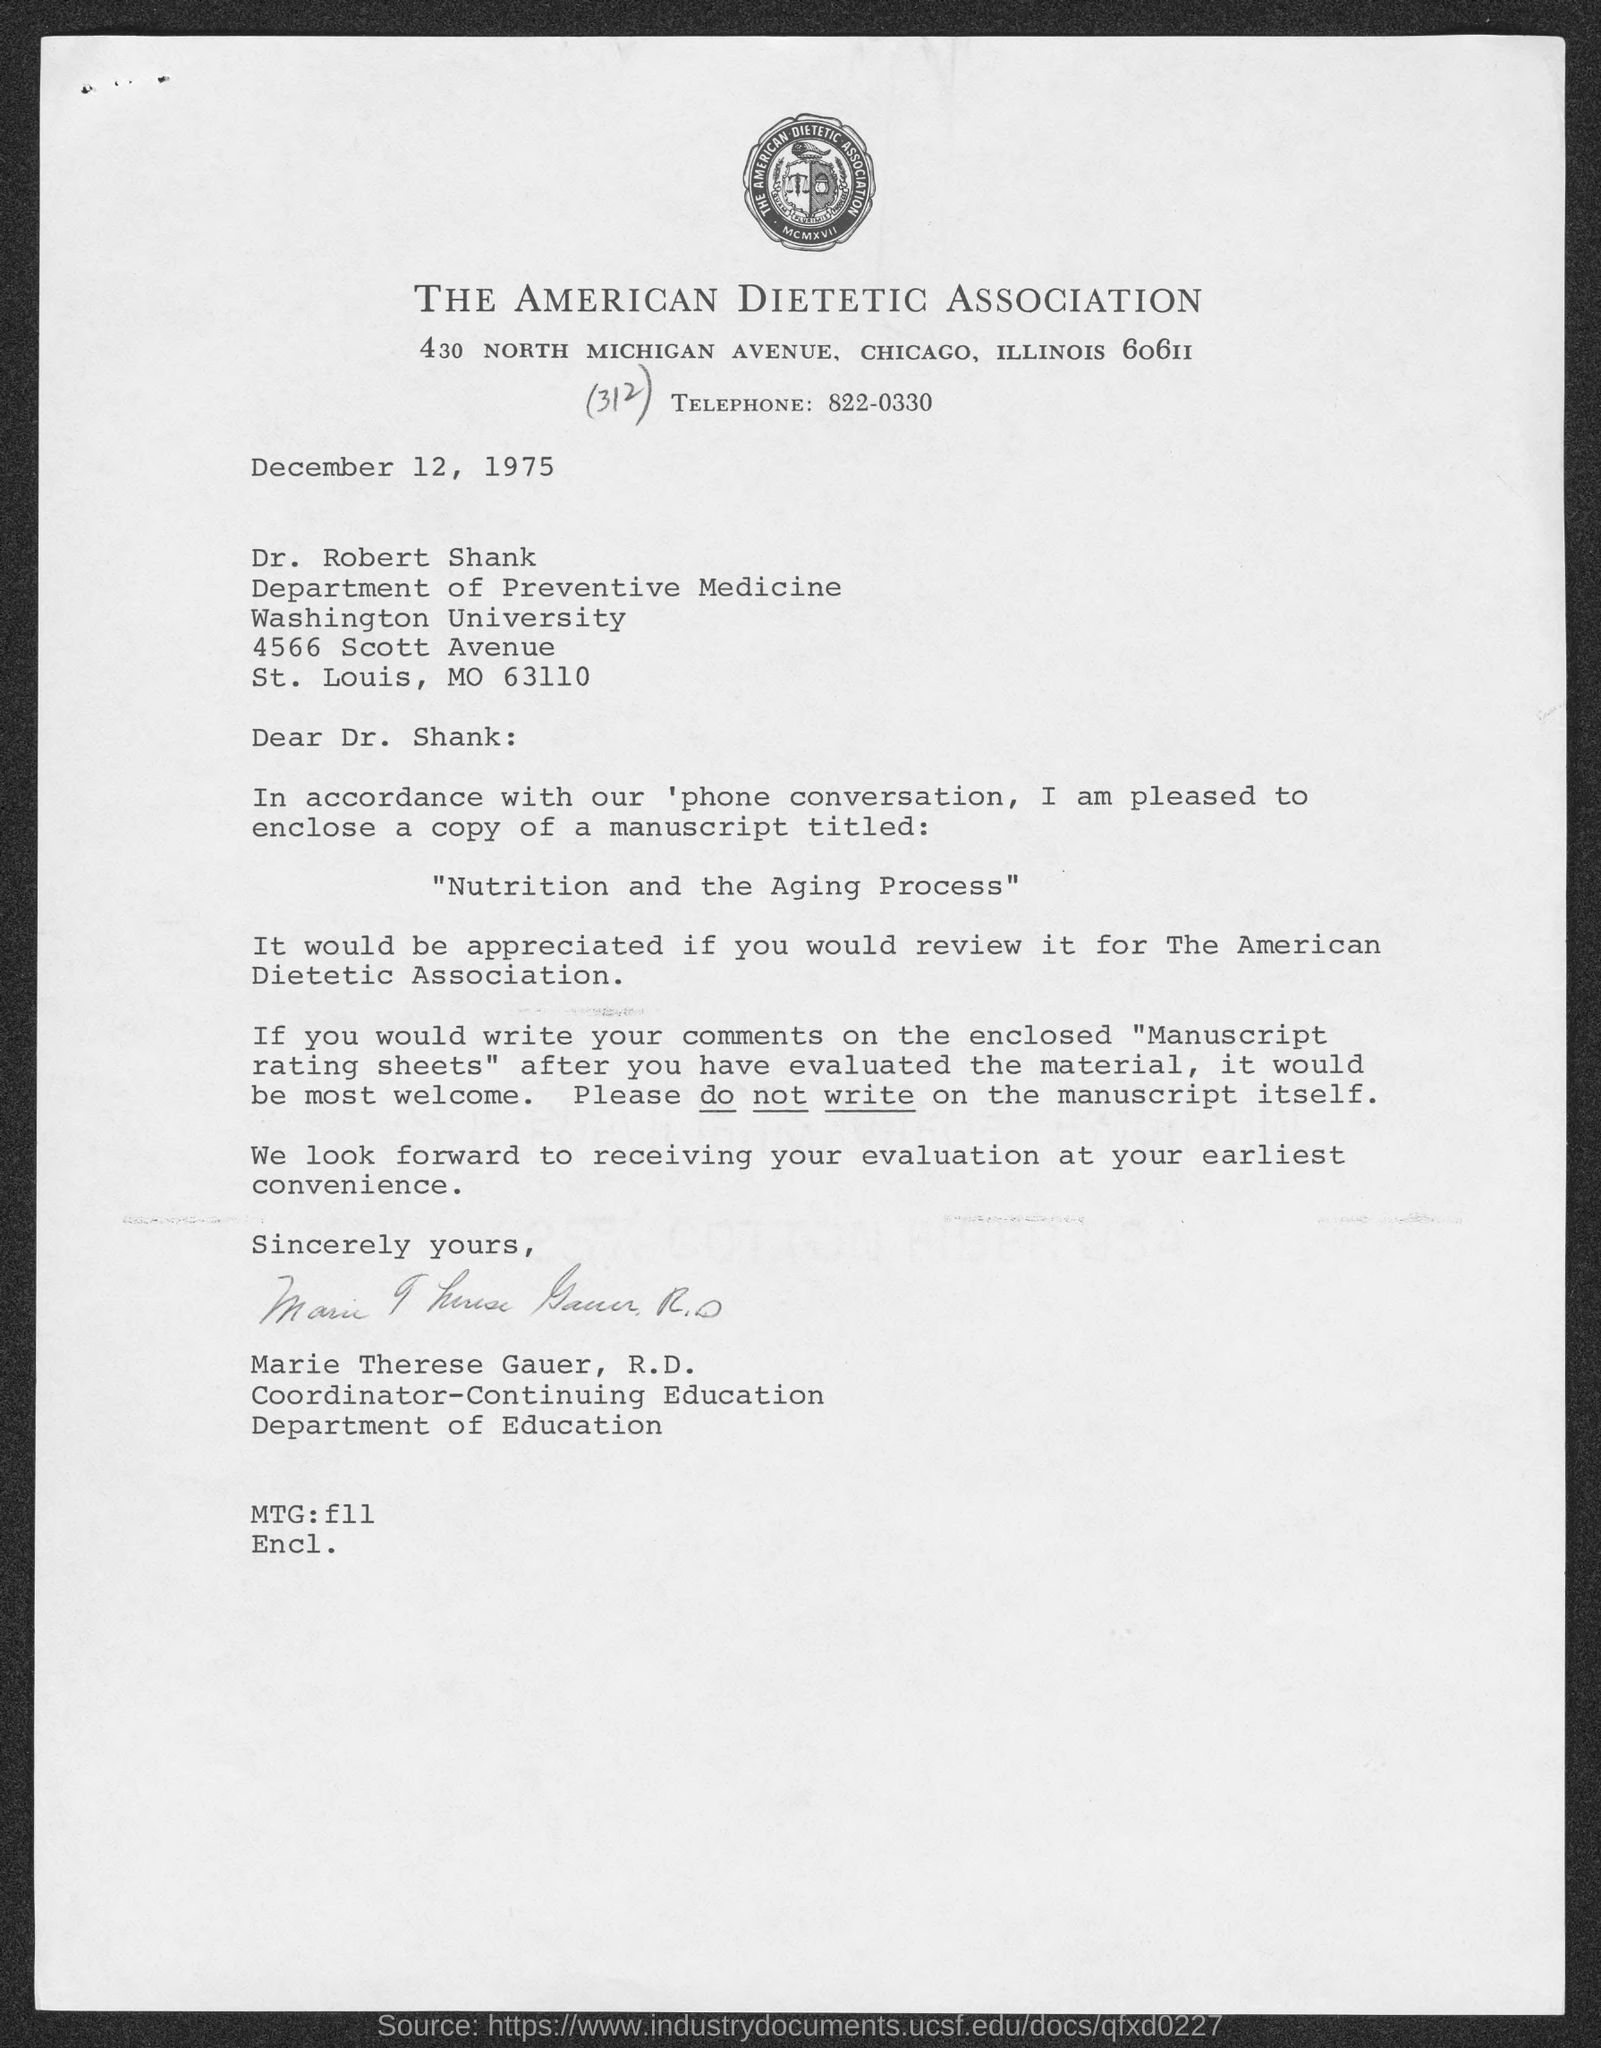What is the Title of the Document ?
Offer a very short reply. The American dietetic association. What is the Telephone Number ?
Ensure brevity in your answer.  822-0330. What is written in the MTG Field ?
Your answer should be very brief. F11. 